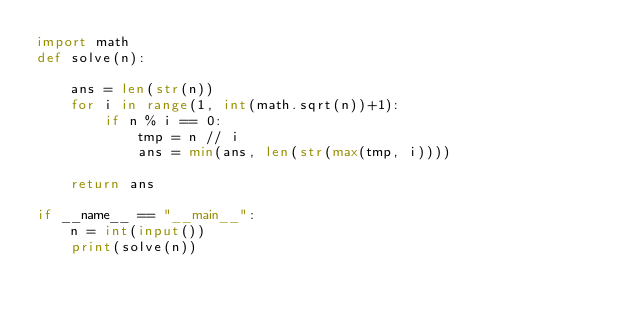Convert code to text. <code><loc_0><loc_0><loc_500><loc_500><_Python_>import math
def solve(n):

    ans = len(str(n))
    for i in range(1, int(math.sqrt(n))+1):
        if n % i == 0:
            tmp = n // i
            ans = min(ans, len(str(max(tmp, i))))

    return ans

if __name__ == "__main__":
    n = int(input())
    print(solve(n))</code> 